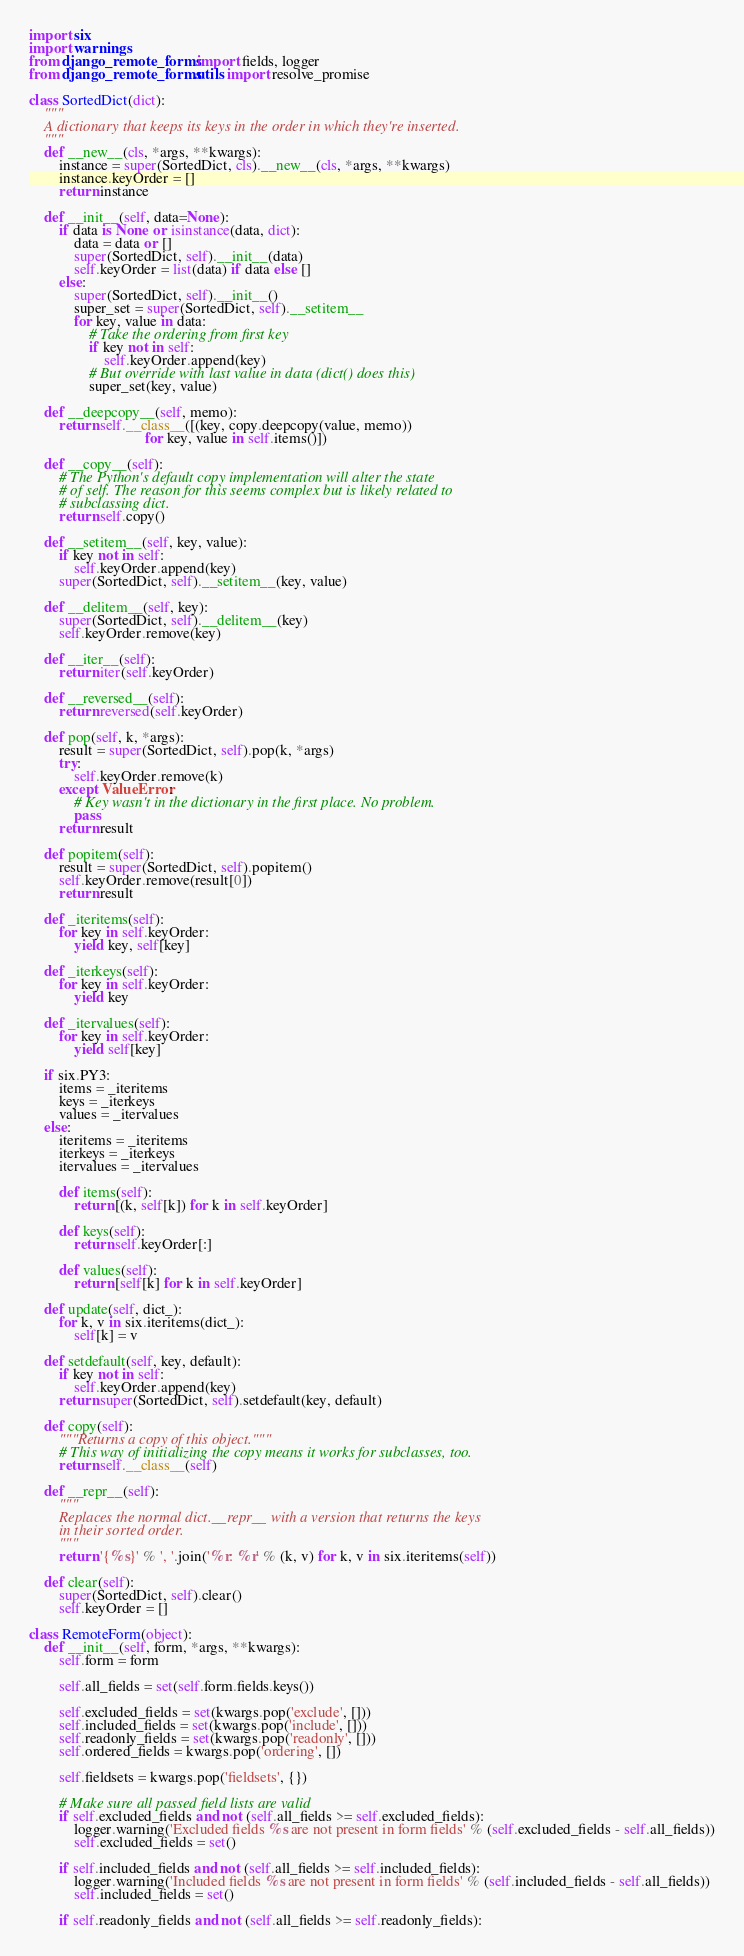<code> <loc_0><loc_0><loc_500><loc_500><_Python_>
import six
import warnings
from django_remote_forms import fields, logger
from django_remote_forms.utils import resolve_promise

class SortedDict(dict):
    """
    A dictionary that keeps its keys in the order in which they're inserted.
    """
    def __new__(cls, *args, **kwargs):
        instance = super(SortedDict, cls).__new__(cls, *args, **kwargs)
        instance.keyOrder = []
        return instance

    def __init__(self, data=None):
        if data is None or isinstance(data, dict):
            data = data or []
            super(SortedDict, self).__init__(data)
            self.keyOrder = list(data) if data else []
        else:
            super(SortedDict, self).__init__()
            super_set = super(SortedDict, self).__setitem__
            for key, value in data:
                # Take the ordering from first key
                if key not in self:
                    self.keyOrder.append(key)
                # But override with last value in data (dict() does this)
                super_set(key, value)

    def __deepcopy__(self, memo):
        return self.__class__([(key, copy.deepcopy(value, memo))
                               for key, value in self.items()])

    def __copy__(self):
        # The Python's default copy implementation will alter the state
        # of self. The reason for this seems complex but is likely related to
        # subclassing dict.
        return self.copy()

    def __setitem__(self, key, value):
        if key not in self:
            self.keyOrder.append(key)
        super(SortedDict, self).__setitem__(key, value)

    def __delitem__(self, key):
        super(SortedDict, self).__delitem__(key)
        self.keyOrder.remove(key)

    def __iter__(self):
        return iter(self.keyOrder)

    def __reversed__(self):
        return reversed(self.keyOrder)

    def pop(self, k, *args):
        result = super(SortedDict, self).pop(k, *args)
        try:
            self.keyOrder.remove(k)
        except ValueError:
            # Key wasn't in the dictionary in the first place. No problem.
            pass
        return result

    def popitem(self):
        result = super(SortedDict, self).popitem()
        self.keyOrder.remove(result[0])
        return result

    def _iteritems(self):
        for key in self.keyOrder:
            yield key, self[key]

    def _iterkeys(self):
        for key in self.keyOrder:
            yield key

    def _itervalues(self):
        for key in self.keyOrder:
            yield self[key]

    if six.PY3:
        items = _iteritems
        keys = _iterkeys
        values = _itervalues
    else:
        iteritems = _iteritems
        iterkeys = _iterkeys
        itervalues = _itervalues

        def items(self):
            return [(k, self[k]) for k in self.keyOrder]

        def keys(self):
            return self.keyOrder[:]

        def values(self):
            return [self[k] for k in self.keyOrder]

    def update(self, dict_):
        for k, v in six.iteritems(dict_):
            self[k] = v

    def setdefault(self, key, default):
        if key not in self:
            self.keyOrder.append(key)
        return super(SortedDict, self).setdefault(key, default)

    def copy(self):
        """Returns a copy of this object."""
        # This way of initializing the copy means it works for subclasses, too.
        return self.__class__(self)

    def __repr__(self):
        """
        Replaces the normal dict.__repr__ with a version that returns the keys
        in their sorted order.
        """
        return '{%s}' % ', '.join('%r: %r' % (k, v) for k, v in six.iteritems(self))

    def clear(self):
        super(SortedDict, self).clear()
        self.keyOrder = []

class RemoteForm(object):
    def __init__(self, form, *args, **kwargs):
        self.form = form

        self.all_fields = set(self.form.fields.keys())

        self.excluded_fields = set(kwargs.pop('exclude', []))
        self.included_fields = set(kwargs.pop('include', []))
        self.readonly_fields = set(kwargs.pop('readonly', []))
        self.ordered_fields = kwargs.pop('ordering', [])

        self.fieldsets = kwargs.pop('fieldsets', {})

        # Make sure all passed field lists are valid
        if self.excluded_fields and not (self.all_fields >= self.excluded_fields):
            logger.warning('Excluded fields %s are not present in form fields' % (self.excluded_fields - self.all_fields))
            self.excluded_fields = set()

        if self.included_fields and not (self.all_fields >= self.included_fields):
            logger.warning('Included fields %s are not present in form fields' % (self.included_fields - self.all_fields))
            self.included_fields = set()

        if self.readonly_fields and not (self.all_fields >= self.readonly_fields):</code> 